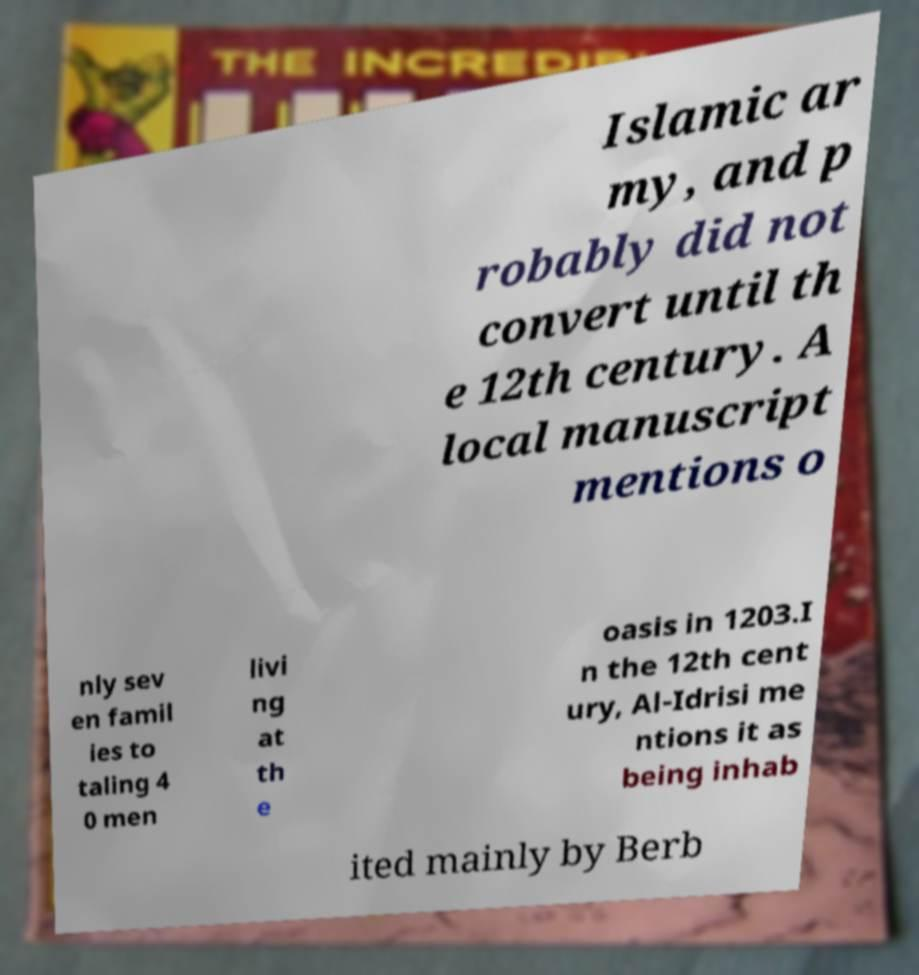Can you accurately transcribe the text from the provided image for me? Islamic ar my, and p robably did not convert until th e 12th century. A local manuscript mentions o nly sev en famil ies to taling 4 0 men livi ng at th e oasis in 1203.I n the 12th cent ury, Al-Idrisi me ntions it as being inhab ited mainly by Berb 